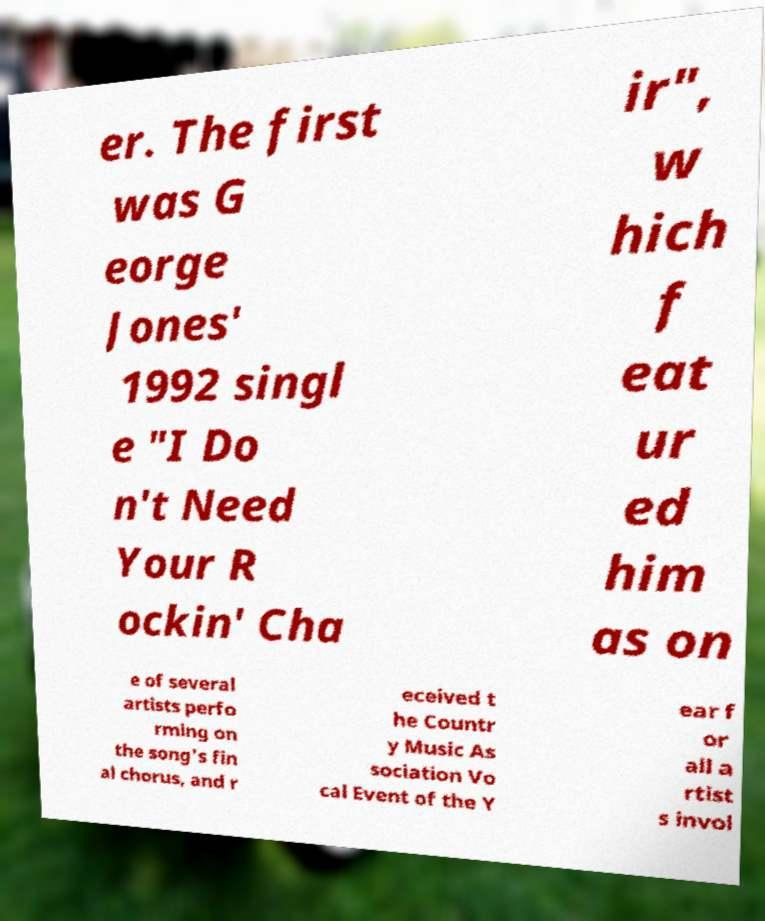Please read and relay the text visible in this image. What does it say? er. The first was G eorge Jones' 1992 singl e "I Do n't Need Your R ockin' Cha ir", w hich f eat ur ed him as on e of several artists perfo rming on the song's fin al chorus, and r eceived t he Countr y Music As sociation Vo cal Event of the Y ear f or all a rtist s invol 